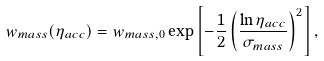<formula> <loc_0><loc_0><loc_500><loc_500>w _ { m a s s } ( \eta _ { a c c } ) = w _ { m a s s , 0 } \exp \left [ - \frac { 1 } { 2 } \left ( \frac { \ln \eta _ { a c c } } { \sigma _ { m a s s } } \right ) ^ { 2 } \right ] ,</formula> 